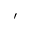Convert formula to latex. <formula><loc_0><loc_0><loc_500><loc_500>\prime</formula> 